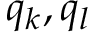<formula> <loc_0><loc_0><loc_500><loc_500>q _ { k } , q _ { l }</formula> 